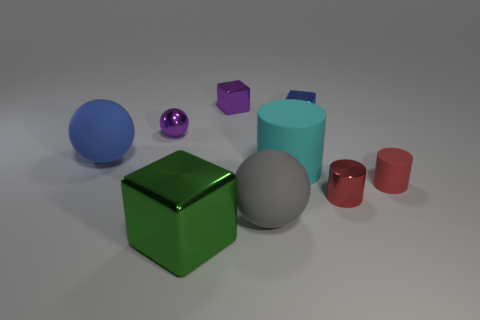There is another tiny cylinder that is the same color as the tiny matte cylinder; what material is it?
Give a very brief answer. Metal. Is the number of rubber balls behind the cyan rubber thing greater than the number of gray matte spheres that are in front of the big gray matte thing?
Offer a terse response. Yes. There is a red cylinder that is on the left side of the red rubber cylinder; is it the same size as the red rubber thing?
Provide a short and direct response. Yes. What number of tiny red things are in front of the block that is in front of the purple metallic thing in front of the blue shiny thing?
Your answer should be compact. 0. What size is the matte object that is both on the left side of the small matte cylinder and in front of the large cyan matte object?
Make the answer very short. Large. What number of other things are there of the same shape as the large gray matte thing?
Offer a terse response. 2. There is a metallic cylinder; how many cylinders are behind it?
Keep it short and to the point. 2. Are there fewer tiny purple shiny spheres left of the big cyan rubber cylinder than objects in front of the red metallic object?
Offer a terse response. Yes. What shape is the small metallic thing that is left of the large green shiny object that is on the left side of the rubber thing that is in front of the small matte thing?
Give a very brief answer. Sphere. What is the shape of the metallic thing that is both behind the tiny ball and in front of the tiny purple shiny cube?
Your answer should be very brief. Cube. 